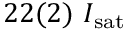Convert formula to latex. <formula><loc_0><loc_0><loc_500><loc_500>2 2 ( 2 ) I _ { s a t }</formula> 